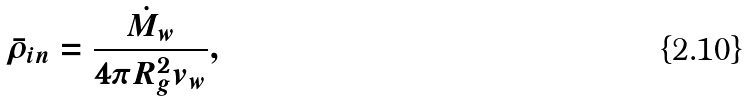Convert formula to latex. <formula><loc_0><loc_0><loc_500><loc_500>\bar { \rho } _ { i n } = \frac { \dot { M } _ { w } } { 4 \pi R _ { g } ^ { 2 } v _ { w } } ,</formula> 